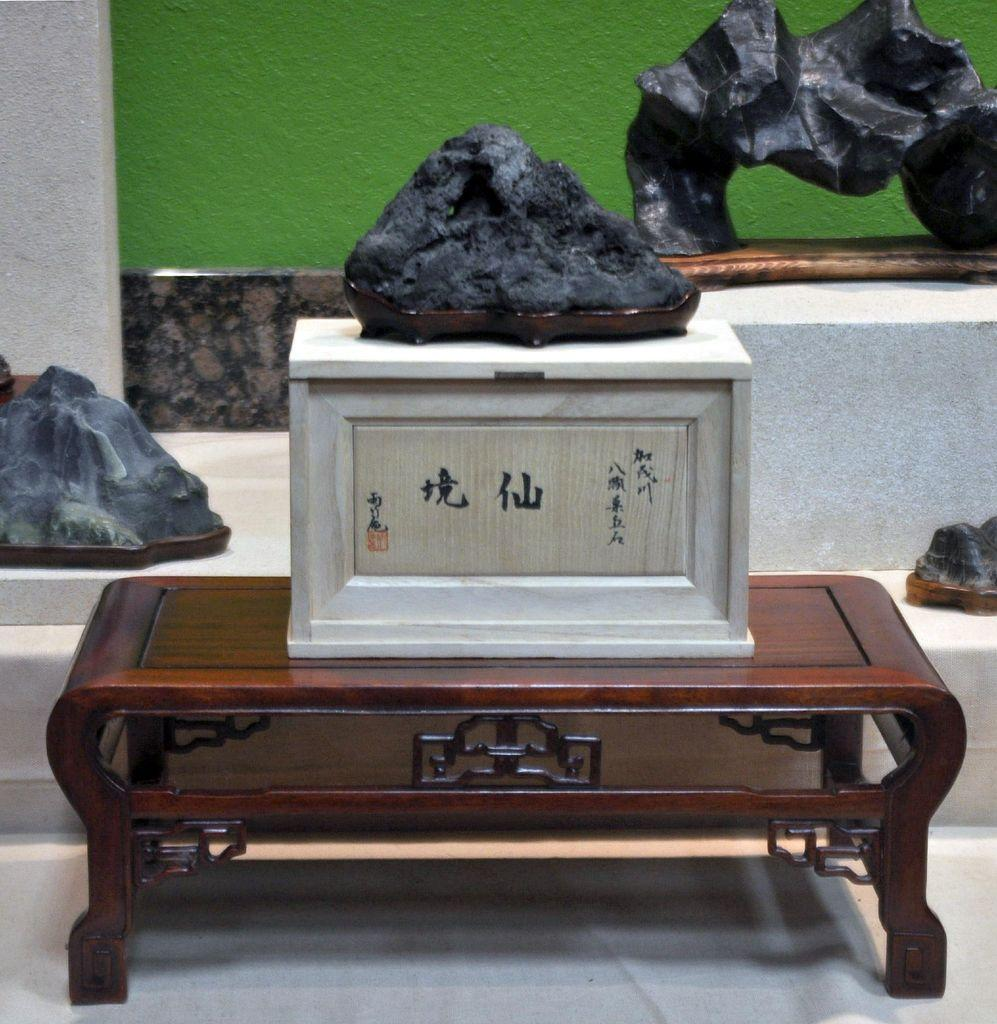What is placed on the floor in the image? There is a table on the floor in the image. What can be found on the table? There is a box in the image. What type of artistic objects are present in the image? There are sculptures in the image. Are there any other objects visible in the image? Yes, there are other objects in the image. What can be seen in the background of the image? There is a wall visible in the background of the image. Can you see any waves crashing against the dock in the image? There is no dock or waves present in the image; it features a table, a box, sculptures, other objects, and a wall in the background. 